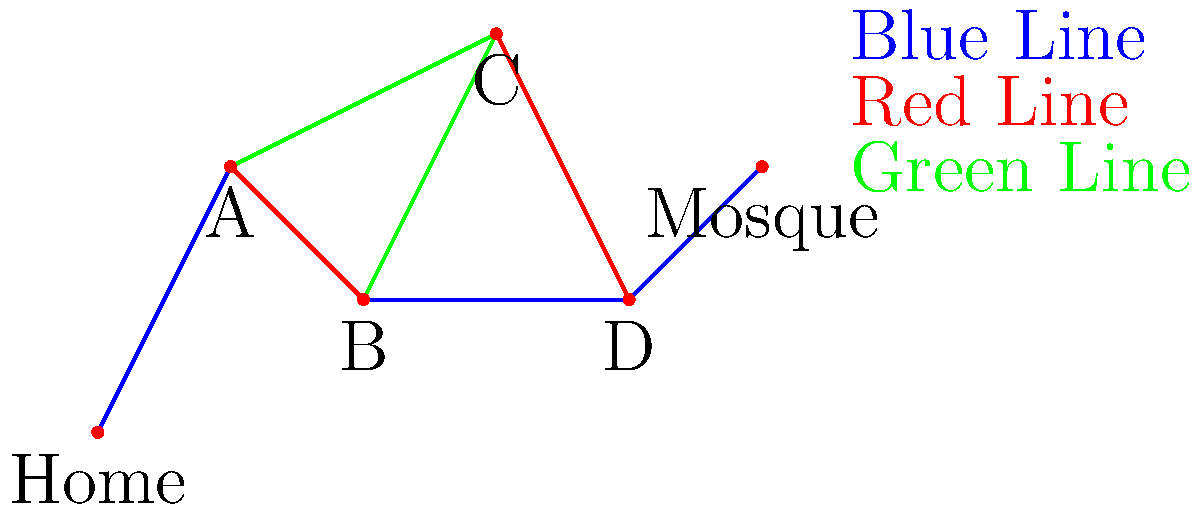Using the transit map provided, determine the most efficient route from Home to the Mosque. Each line (Blue, Red, and Green) represents a different bus route, and transferring between lines takes an additional 5 minutes. Assume that travel time between any two adjacent stations is 10 minutes, regardless of the line. What is the minimum time required to reach the Mosque? Let's analyze the possible routes from Home to the Mosque:

1. Home -> A -> B -> C -> D -> Mosque
   - Blue line: Home to A (10 min)
   - Transfer to Red line at A (5 min)
   - Red line: A to B (10 min)
   - Transfer to Green line at B (5 min)
   - Green line: B to C (10 min)
   - Transfer to Red line at C (5 min)
   - Red line: C to D (10 min)
   - Transfer to Blue line at D (5 min)
   - Blue line: D to Mosque (10 min)
   Total time: $10 + 5 + 10 + 5 + 10 + 5 + 10 + 5 + 10 = 70$ minutes

2. Home -> A -> C -> D -> Mosque
   - Blue line: Home to A (10 min)
   - Transfer to Green line at A (5 min)
   - Green line: A to C (10 min)
   - Transfer to Red line at C (5 min)
   - Red line: C to D (10 min)
   - Transfer to Blue line at D (5 min)
   - Blue line: D to Mosque (10 min)
   Total time: $10 + 5 + 10 + 5 + 10 + 5 + 10 = 55$ minutes

3. Home -> A -> B -> D -> Mosque
   - Blue line: Home to A (10 min)
   - Transfer to Red line at A (5 min)
   - Red line: A to B (10 min)
   - Transfer to Blue line at B (5 min)
   - Blue line: B to D (10 min)
   - Blue line: D to Mosque (10 min)
   Total time: $10 + 5 + 10 + 5 + 10 + 10 = 50$ minutes

The most efficient route is option 3, which takes 50 minutes.
Answer: 50 minutes 